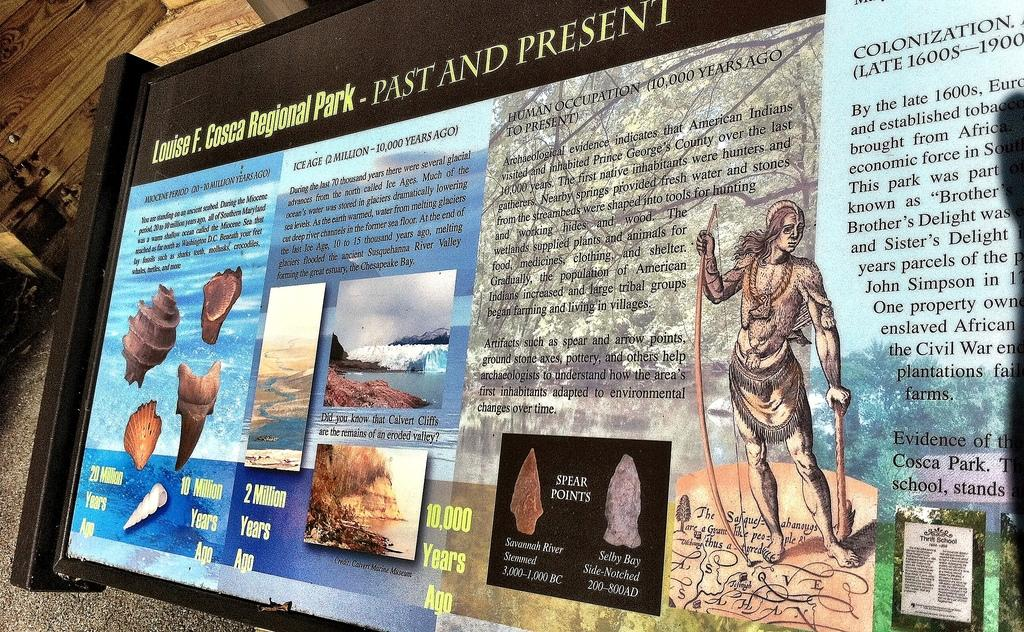<image>
Present a compact description of the photo's key features. A presentation of ancient artifacts and shells titled past and present. 